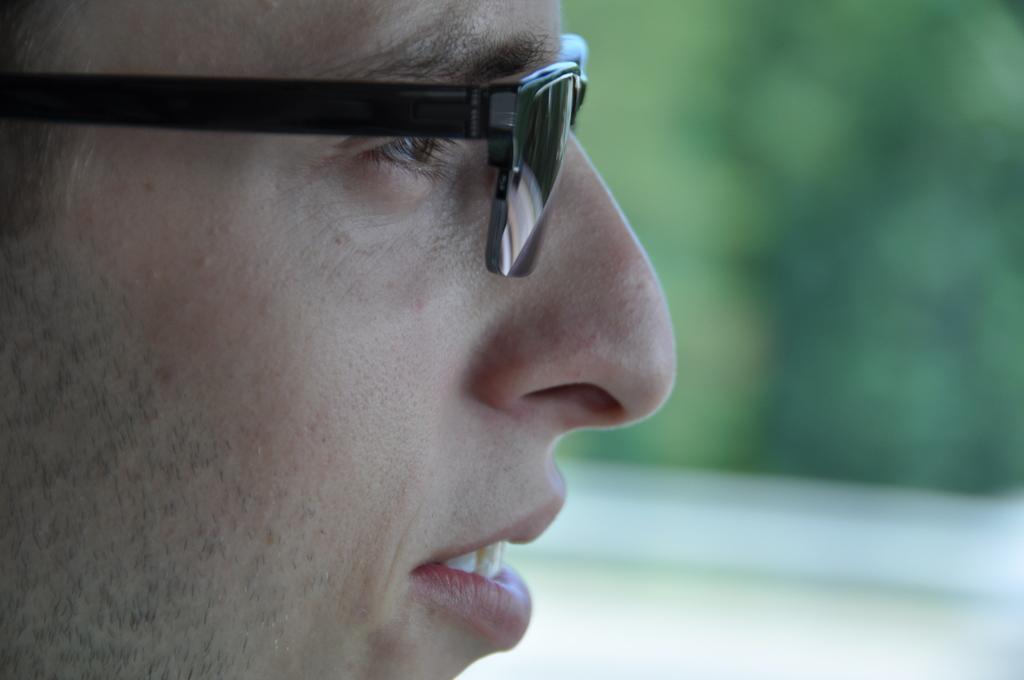In one or two sentences, can you explain what this image depicts? In this picture we can see a man in the front, he wore spectacles, we can see a blurry background. 